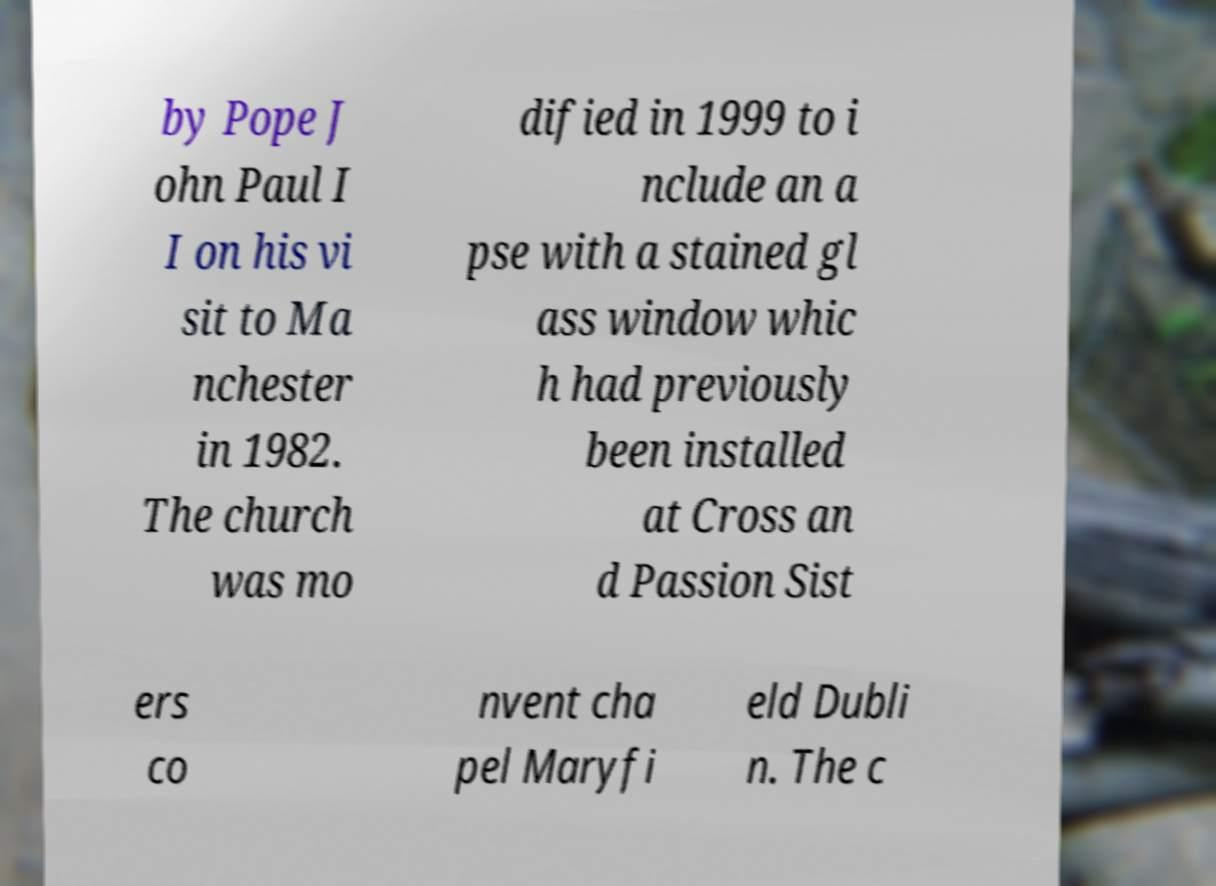Please read and relay the text visible in this image. What does it say? by Pope J ohn Paul I I on his vi sit to Ma nchester in 1982. The church was mo dified in 1999 to i nclude an a pse with a stained gl ass window whic h had previously been installed at Cross an d Passion Sist ers co nvent cha pel Maryfi eld Dubli n. The c 